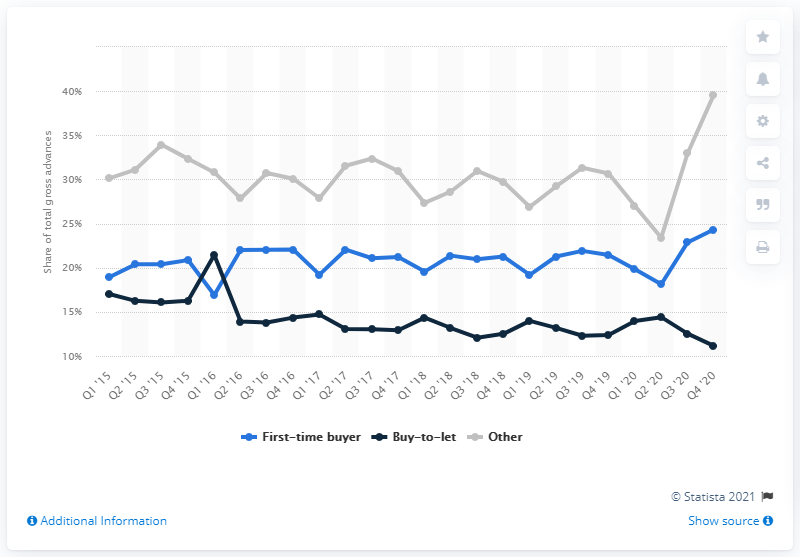Mention a couple of crucial points in this snapshot. In the fourth quarter of 2020, the share of gross advances for first-time buyers was 24.32%. 